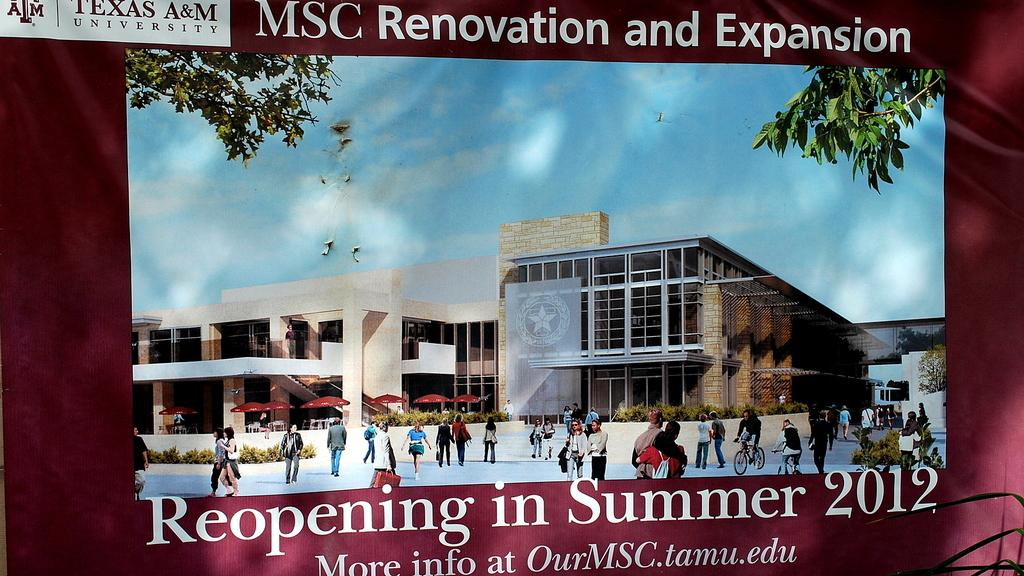What is featured on the banner in the image? The banner has an image of a building. What can be seen near the building in the image? There are people walking near the building. What is visible behind the building in the image? The sky is visible behind the building. What type of weather is suggested by the clouds in the image? The presence of clouds in the sky suggests that the weather might be partly cloudy. What type of paper is being used to rate the ground in the image? There is no paper or ground rating activity present in the image. 